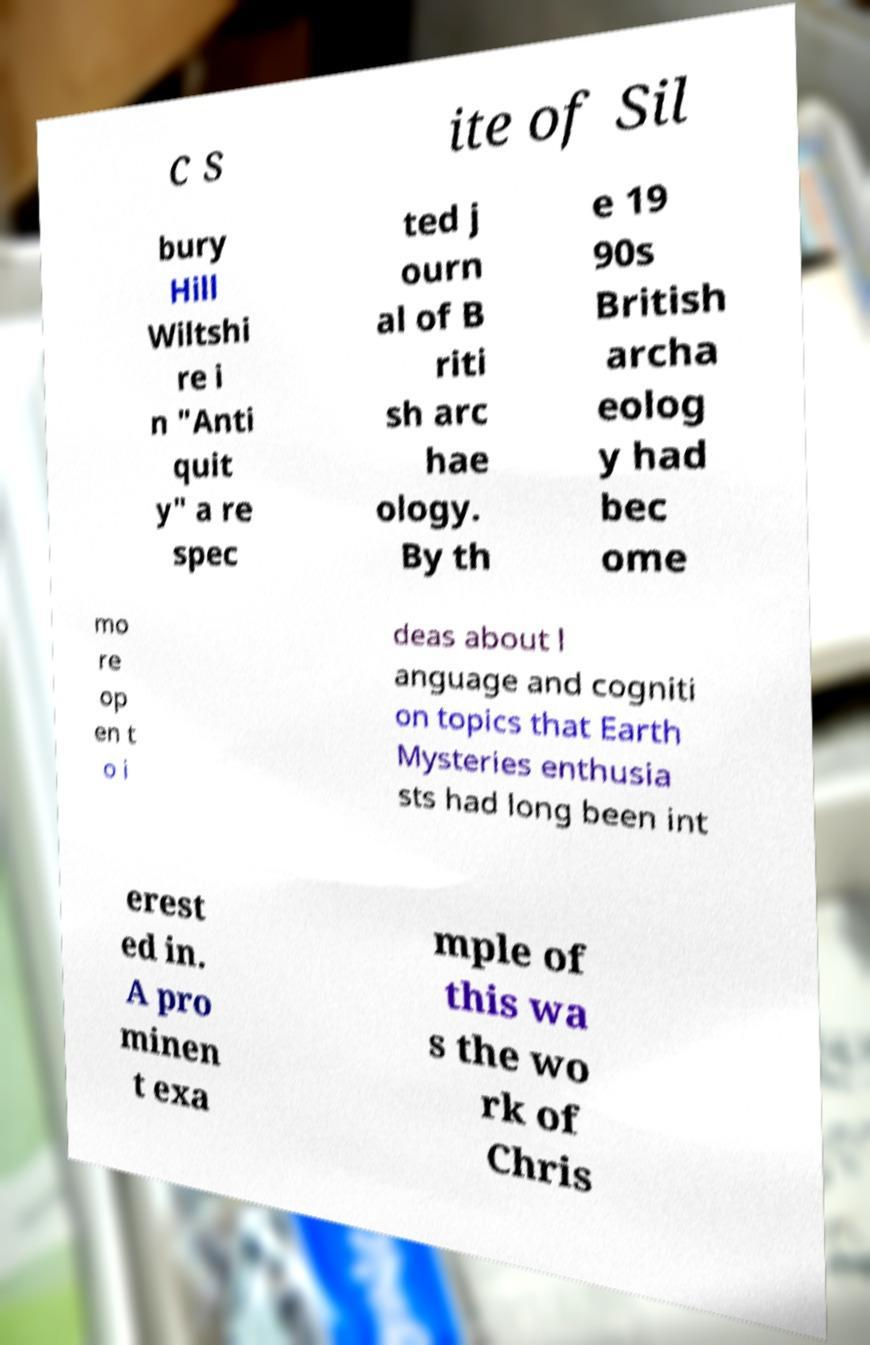There's text embedded in this image that I need extracted. Can you transcribe it verbatim? c s ite of Sil bury Hill Wiltshi re i n "Anti quit y" a re spec ted j ourn al of B riti sh arc hae ology. By th e 19 90s British archa eolog y had bec ome mo re op en t o i deas about l anguage and cogniti on topics that Earth Mysteries enthusia sts had long been int erest ed in. A pro minen t exa mple of this wa s the wo rk of Chris 